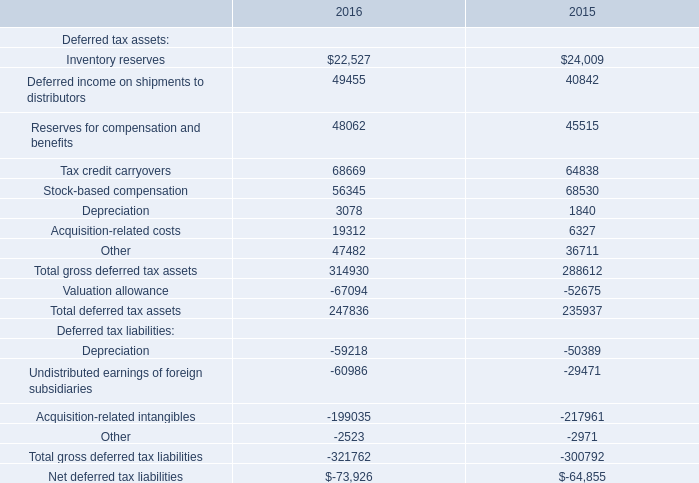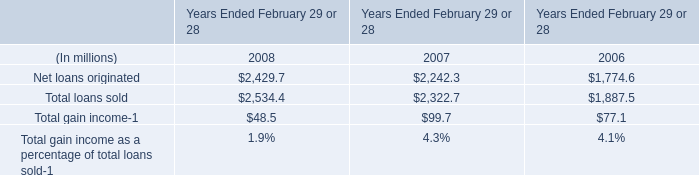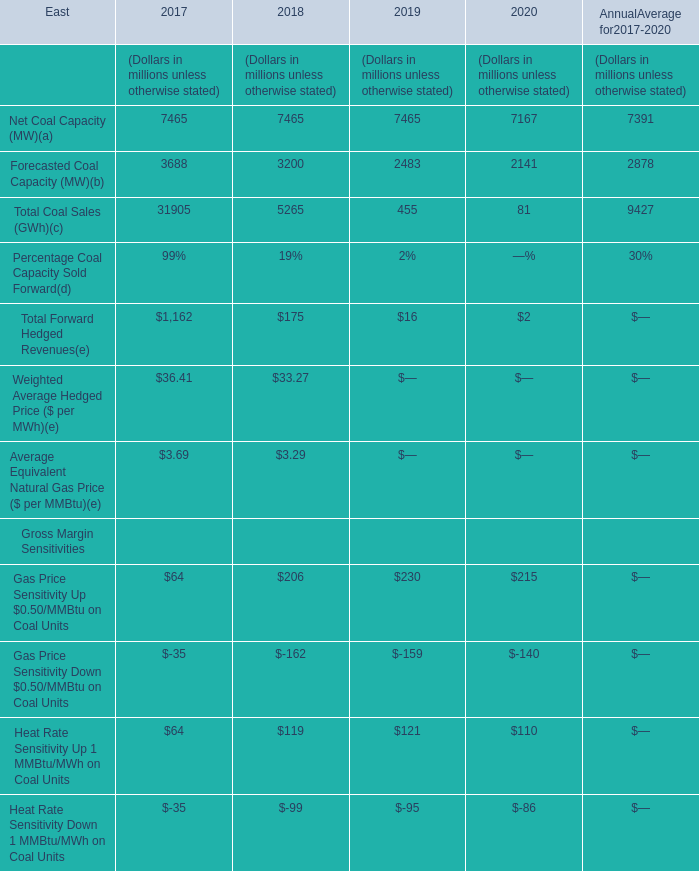What is the percentage of all Gross Margin Sensitivities that are positive to the total amount, in 2019? 
Computations: ((230 + 121) / (((230 + 121) - 159) - 95))
Answer: 3.61856. 